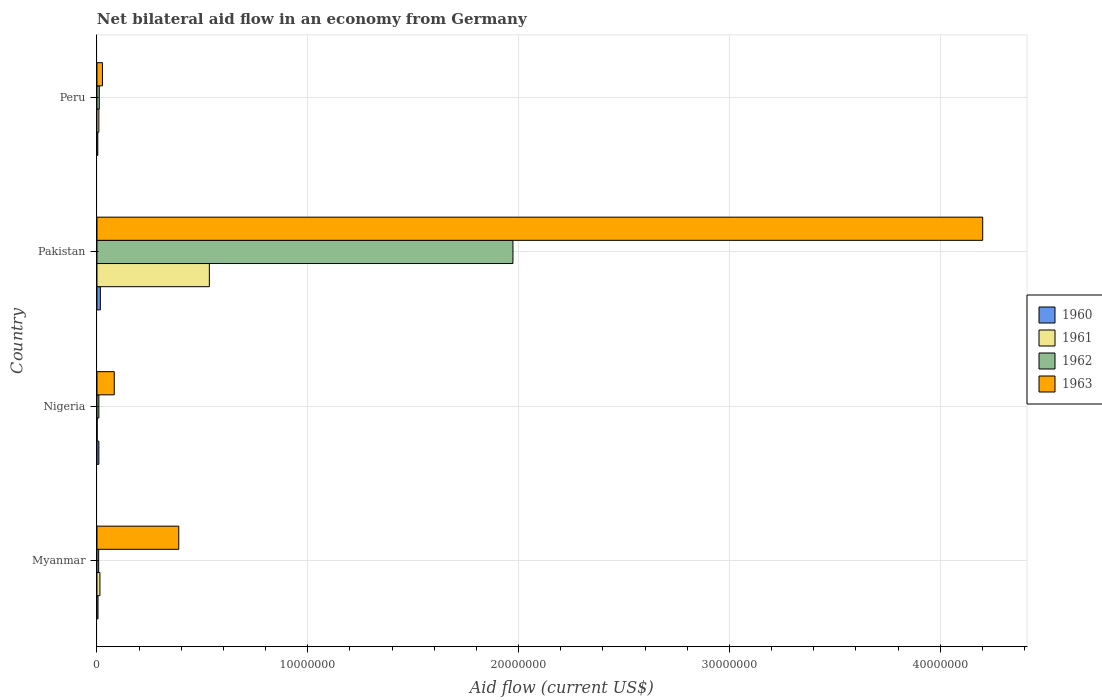How many groups of bars are there?
Make the answer very short. 4. Are the number of bars per tick equal to the number of legend labels?
Offer a terse response. Yes. How many bars are there on the 3rd tick from the top?
Your answer should be very brief. 4. What is the label of the 4th group of bars from the top?
Ensure brevity in your answer.  Myanmar. In how many cases, is the number of bars for a given country not equal to the number of legend labels?
Offer a terse response. 0. What is the net bilateral aid flow in 1961 in Nigeria?
Keep it short and to the point. 10000. Across all countries, what is the maximum net bilateral aid flow in 1960?
Your answer should be very brief. 1.60e+05. Across all countries, what is the minimum net bilateral aid flow in 1963?
Your answer should be compact. 2.60e+05. In which country was the net bilateral aid flow in 1961 minimum?
Offer a terse response. Nigeria. What is the total net bilateral aid flow in 1963 in the graph?
Offer a very short reply. 4.70e+07. What is the difference between the net bilateral aid flow in 1961 in Myanmar and that in Peru?
Keep it short and to the point. 5.00e+04. What is the average net bilateral aid flow in 1962 per country?
Make the answer very short. 5.00e+06. What is the difference between the net bilateral aid flow in 1960 and net bilateral aid flow in 1963 in Nigeria?
Provide a short and direct response. -7.30e+05. What is the ratio of the net bilateral aid flow in 1962 in Myanmar to that in Nigeria?
Provide a short and direct response. 0.89. Is the net bilateral aid flow in 1962 in Pakistan less than that in Peru?
Your response must be concise. No. What is the difference between the highest and the second highest net bilateral aid flow in 1962?
Keep it short and to the point. 1.96e+07. In how many countries, is the net bilateral aid flow in 1961 greater than the average net bilateral aid flow in 1961 taken over all countries?
Give a very brief answer. 1. Is the sum of the net bilateral aid flow in 1962 in Myanmar and Nigeria greater than the maximum net bilateral aid flow in 1961 across all countries?
Give a very brief answer. No. What does the 2nd bar from the top in Myanmar represents?
Give a very brief answer. 1962. How many bars are there?
Give a very brief answer. 16. Are all the bars in the graph horizontal?
Make the answer very short. Yes. What is the difference between two consecutive major ticks on the X-axis?
Ensure brevity in your answer.  1.00e+07. Does the graph contain any zero values?
Offer a very short reply. No. How are the legend labels stacked?
Give a very brief answer. Vertical. What is the title of the graph?
Your answer should be compact. Net bilateral aid flow in an economy from Germany. What is the label or title of the Y-axis?
Offer a terse response. Country. What is the Aid flow (current US$) of 1961 in Myanmar?
Keep it short and to the point. 1.40e+05. What is the Aid flow (current US$) in 1962 in Myanmar?
Your response must be concise. 8.00e+04. What is the Aid flow (current US$) of 1963 in Myanmar?
Keep it short and to the point. 3.88e+06. What is the Aid flow (current US$) in 1960 in Nigeria?
Provide a short and direct response. 9.00e+04. What is the Aid flow (current US$) in 1961 in Nigeria?
Give a very brief answer. 10000. What is the Aid flow (current US$) of 1963 in Nigeria?
Give a very brief answer. 8.20e+05. What is the Aid flow (current US$) in 1960 in Pakistan?
Your answer should be compact. 1.60e+05. What is the Aid flow (current US$) in 1961 in Pakistan?
Your response must be concise. 5.33e+06. What is the Aid flow (current US$) in 1962 in Pakistan?
Keep it short and to the point. 1.97e+07. What is the Aid flow (current US$) of 1963 in Pakistan?
Your response must be concise. 4.20e+07. What is the Aid flow (current US$) of 1960 in Peru?
Give a very brief answer. 4.00e+04. What is the Aid flow (current US$) in 1962 in Peru?
Offer a very short reply. 1.10e+05. Across all countries, what is the maximum Aid flow (current US$) of 1961?
Your answer should be compact. 5.33e+06. Across all countries, what is the maximum Aid flow (current US$) in 1962?
Offer a very short reply. 1.97e+07. Across all countries, what is the maximum Aid flow (current US$) of 1963?
Your response must be concise. 4.20e+07. Across all countries, what is the minimum Aid flow (current US$) of 1960?
Give a very brief answer. 4.00e+04. Across all countries, what is the minimum Aid flow (current US$) in 1962?
Keep it short and to the point. 8.00e+04. What is the total Aid flow (current US$) of 1961 in the graph?
Ensure brevity in your answer.  5.57e+06. What is the total Aid flow (current US$) of 1962 in the graph?
Your answer should be compact. 2.00e+07. What is the total Aid flow (current US$) in 1963 in the graph?
Your answer should be very brief. 4.70e+07. What is the difference between the Aid flow (current US$) in 1960 in Myanmar and that in Nigeria?
Your answer should be compact. -4.00e+04. What is the difference between the Aid flow (current US$) in 1963 in Myanmar and that in Nigeria?
Your answer should be very brief. 3.06e+06. What is the difference between the Aid flow (current US$) in 1961 in Myanmar and that in Pakistan?
Offer a very short reply. -5.19e+06. What is the difference between the Aid flow (current US$) of 1962 in Myanmar and that in Pakistan?
Provide a short and direct response. -1.96e+07. What is the difference between the Aid flow (current US$) in 1963 in Myanmar and that in Pakistan?
Give a very brief answer. -3.81e+07. What is the difference between the Aid flow (current US$) of 1961 in Myanmar and that in Peru?
Your response must be concise. 5.00e+04. What is the difference between the Aid flow (current US$) of 1963 in Myanmar and that in Peru?
Keep it short and to the point. 3.62e+06. What is the difference between the Aid flow (current US$) of 1961 in Nigeria and that in Pakistan?
Your answer should be compact. -5.32e+06. What is the difference between the Aid flow (current US$) in 1962 in Nigeria and that in Pakistan?
Ensure brevity in your answer.  -1.96e+07. What is the difference between the Aid flow (current US$) in 1963 in Nigeria and that in Pakistan?
Make the answer very short. -4.12e+07. What is the difference between the Aid flow (current US$) in 1960 in Nigeria and that in Peru?
Offer a terse response. 5.00e+04. What is the difference between the Aid flow (current US$) of 1962 in Nigeria and that in Peru?
Provide a succinct answer. -2.00e+04. What is the difference between the Aid flow (current US$) of 1963 in Nigeria and that in Peru?
Your answer should be very brief. 5.60e+05. What is the difference between the Aid flow (current US$) of 1960 in Pakistan and that in Peru?
Provide a short and direct response. 1.20e+05. What is the difference between the Aid flow (current US$) in 1961 in Pakistan and that in Peru?
Keep it short and to the point. 5.24e+06. What is the difference between the Aid flow (current US$) of 1962 in Pakistan and that in Peru?
Your answer should be compact. 1.96e+07. What is the difference between the Aid flow (current US$) of 1963 in Pakistan and that in Peru?
Keep it short and to the point. 4.18e+07. What is the difference between the Aid flow (current US$) of 1960 in Myanmar and the Aid flow (current US$) of 1963 in Nigeria?
Make the answer very short. -7.70e+05. What is the difference between the Aid flow (current US$) in 1961 in Myanmar and the Aid flow (current US$) in 1963 in Nigeria?
Your response must be concise. -6.80e+05. What is the difference between the Aid flow (current US$) of 1962 in Myanmar and the Aid flow (current US$) of 1963 in Nigeria?
Give a very brief answer. -7.40e+05. What is the difference between the Aid flow (current US$) of 1960 in Myanmar and the Aid flow (current US$) of 1961 in Pakistan?
Make the answer very short. -5.28e+06. What is the difference between the Aid flow (current US$) of 1960 in Myanmar and the Aid flow (current US$) of 1962 in Pakistan?
Your answer should be compact. -1.97e+07. What is the difference between the Aid flow (current US$) of 1960 in Myanmar and the Aid flow (current US$) of 1963 in Pakistan?
Provide a short and direct response. -4.20e+07. What is the difference between the Aid flow (current US$) in 1961 in Myanmar and the Aid flow (current US$) in 1962 in Pakistan?
Give a very brief answer. -1.96e+07. What is the difference between the Aid flow (current US$) of 1961 in Myanmar and the Aid flow (current US$) of 1963 in Pakistan?
Provide a short and direct response. -4.19e+07. What is the difference between the Aid flow (current US$) of 1962 in Myanmar and the Aid flow (current US$) of 1963 in Pakistan?
Offer a very short reply. -4.19e+07. What is the difference between the Aid flow (current US$) of 1960 in Myanmar and the Aid flow (current US$) of 1961 in Peru?
Make the answer very short. -4.00e+04. What is the difference between the Aid flow (current US$) of 1961 in Myanmar and the Aid flow (current US$) of 1962 in Peru?
Ensure brevity in your answer.  3.00e+04. What is the difference between the Aid flow (current US$) of 1961 in Myanmar and the Aid flow (current US$) of 1963 in Peru?
Your answer should be compact. -1.20e+05. What is the difference between the Aid flow (current US$) of 1960 in Nigeria and the Aid flow (current US$) of 1961 in Pakistan?
Ensure brevity in your answer.  -5.24e+06. What is the difference between the Aid flow (current US$) of 1960 in Nigeria and the Aid flow (current US$) of 1962 in Pakistan?
Provide a succinct answer. -1.96e+07. What is the difference between the Aid flow (current US$) of 1960 in Nigeria and the Aid flow (current US$) of 1963 in Pakistan?
Keep it short and to the point. -4.19e+07. What is the difference between the Aid flow (current US$) of 1961 in Nigeria and the Aid flow (current US$) of 1962 in Pakistan?
Your response must be concise. -1.97e+07. What is the difference between the Aid flow (current US$) of 1961 in Nigeria and the Aid flow (current US$) of 1963 in Pakistan?
Provide a succinct answer. -4.20e+07. What is the difference between the Aid flow (current US$) in 1962 in Nigeria and the Aid flow (current US$) in 1963 in Pakistan?
Give a very brief answer. -4.19e+07. What is the difference between the Aid flow (current US$) in 1960 in Nigeria and the Aid flow (current US$) in 1961 in Peru?
Provide a short and direct response. 0. What is the difference between the Aid flow (current US$) in 1960 in Nigeria and the Aid flow (current US$) in 1962 in Peru?
Your answer should be very brief. -2.00e+04. What is the difference between the Aid flow (current US$) in 1960 in Pakistan and the Aid flow (current US$) in 1961 in Peru?
Keep it short and to the point. 7.00e+04. What is the difference between the Aid flow (current US$) in 1961 in Pakistan and the Aid flow (current US$) in 1962 in Peru?
Give a very brief answer. 5.22e+06. What is the difference between the Aid flow (current US$) of 1961 in Pakistan and the Aid flow (current US$) of 1963 in Peru?
Your answer should be very brief. 5.07e+06. What is the difference between the Aid flow (current US$) in 1962 in Pakistan and the Aid flow (current US$) in 1963 in Peru?
Your response must be concise. 1.95e+07. What is the average Aid flow (current US$) in 1960 per country?
Your response must be concise. 8.50e+04. What is the average Aid flow (current US$) of 1961 per country?
Ensure brevity in your answer.  1.39e+06. What is the average Aid flow (current US$) of 1962 per country?
Ensure brevity in your answer.  5.00e+06. What is the average Aid flow (current US$) of 1963 per country?
Provide a succinct answer. 1.17e+07. What is the difference between the Aid flow (current US$) in 1960 and Aid flow (current US$) in 1961 in Myanmar?
Your response must be concise. -9.00e+04. What is the difference between the Aid flow (current US$) in 1960 and Aid flow (current US$) in 1963 in Myanmar?
Your answer should be compact. -3.83e+06. What is the difference between the Aid flow (current US$) of 1961 and Aid flow (current US$) of 1962 in Myanmar?
Offer a terse response. 6.00e+04. What is the difference between the Aid flow (current US$) of 1961 and Aid flow (current US$) of 1963 in Myanmar?
Your answer should be very brief. -3.74e+06. What is the difference between the Aid flow (current US$) in 1962 and Aid flow (current US$) in 1963 in Myanmar?
Keep it short and to the point. -3.80e+06. What is the difference between the Aid flow (current US$) of 1960 and Aid flow (current US$) of 1961 in Nigeria?
Make the answer very short. 8.00e+04. What is the difference between the Aid flow (current US$) in 1960 and Aid flow (current US$) in 1962 in Nigeria?
Give a very brief answer. 0. What is the difference between the Aid flow (current US$) of 1960 and Aid flow (current US$) of 1963 in Nigeria?
Offer a terse response. -7.30e+05. What is the difference between the Aid flow (current US$) in 1961 and Aid flow (current US$) in 1962 in Nigeria?
Keep it short and to the point. -8.00e+04. What is the difference between the Aid flow (current US$) in 1961 and Aid flow (current US$) in 1963 in Nigeria?
Keep it short and to the point. -8.10e+05. What is the difference between the Aid flow (current US$) of 1962 and Aid flow (current US$) of 1963 in Nigeria?
Make the answer very short. -7.30e+05. What is the difference between the Aid flow (current US$) in 1960 and Aid flow (current US$) in 1961 in Pakistan?
Keep it short and to the point. -5.17e+06. What is the difference between the Aid flow (current US$) of 1960 and Aid flow (current US$) of 1962 in Pakistan?
Make the answer very short. -1.96e+07. What is the difference between the Aid flow (current US$) in 1960 and Aid flow (current US$) in 1963 in Pakistan?
Your answer should be very brief. -4.18e+07. What is the difference between the Aid flow (current US$) of 1961 and Aid flow (current US$) of 1962 in Pakistan?
Make the answer very short. -1.44e+07. What is the difference between the Aid flow (current US$) in 1961 and Aid flow (current US$) in 1963 in Pakistan?
Make the answer very short. -3.67e+07. What is the difference between the Aid flow (current US$) in 1962 and Aid flow (current US$) in 1963 in Pakistan?
Keep it short and to the point. -2.23e+07. What is the difference between the Aid flow (current US$) in 1960 and Aid flow (current US$) in 1961 in Peru?
Provide a short and direct response. -5.00e+04. What is the difference between the Aid flow (current US$) of 1960 and Aid flow (current US$) of 1962 in Peru?
Offer a very short reply. -7.00e+04. What is the difference between the Aid flow (current US$) in 1961 and Aid flow (current US$) in 1963 in Peru?
Your response must be concise. -1.70e+05. What is the ratio of the Aid flow (current US$) in 1960 in Myanmar to that in Nigeria?
Keep it short and to the point. 0.56. What is the ratio of the Aid flow (current US$) in 1961 in Myanmar to that in Nigeria?
Give a very brief answer. 14. What is the ratio of the Aid flow (current US$) in 1963 in Myanmar to that in Nigeria?
Offer a terse response. 4.73. What is the ratio of the Aid flow (current US$) of 1960 in Myanmar to that in Pakistan?
Offer a terse response. 0.31. What is the ratio of the Aid flow (current US$) of 1961 in Myanmar to that in Pakistan?
Give a very brief answer. 0.03. What is the ratio of the Aid flow (current US$) of 1962 in Myanmar to that in Pakistan?
Keep it short and to the point. 0. What is the ratio of the Aid flow (current US$) of 1963 in Myanmar to that in Pakistan?
Make the answer very short. 0.09. What is the ratio of the Aid flow (current US$) in 1961 in Myanmar to that in Peru?
Make the answer very short. 1.56. What is the ratio of the Aid flow (current US$) in 1962 in Myanmar to that in Peru?
Ensure brevity in your answer.  0.73. What is the ratio of the Aid flow (current US$) of 1963 in Myanmar to that in Peru?
Offer a very short reply. 14.92. What is the ratio of the Aid flow (current US$) in 1960 in Nigeria to that in Pakistan?
Give a very brief answer. 0.56. What is the ratio of the Aid flow (current US$) in 1961 in Nigeria to that in Pakistan?
Offer a very short reply. 0. What is the ratio of the Aid flow (current US$) of 1962 in Nigeria to that in Pakistan?
Provide a succinct answer. 0. What is the ratio of the Aid flow (current US$) of 1963 in Nigeria to that in Pakistan?
Your answer should be compact. 0.02. What is the ratio of the Aid flow (current US$) of 1960 in Nigeria to that in Peru?
Your answer should be compact. 2.25. What is the ratio of the Aid flow (current US$) in 1962 in Nigeria to that in Peru?
Your response must be concise. 0.82. What is the ratio of the Aid flow (current US$) of 1963 in Nigeria to that in Peru?
Make the answer very short. 3.15. What is the ratio of the Aid flow (current US$) of 1960 in Pakistan to that in Peru?
Offer a very short reply. 4. What is the ratio of the Aid flow (current US$) in 1961 in Pakistan to that in Peru?
Offer a terse response. 59.22. What is the ratio of the Aid flow (current US$) in 1962 in Pakistan to that in Peru?
Your answer should be very brief. 179.36. What is the ratio of the Aid flow (current US$) in 1963 in Pakistan to that in Peru?
Provide a short and direct response. 161.58. What is the difference between the highest and the second highest Aid flow (current US$) of 1961?
Your response must be concise. 5.19e+06. What is the difference between the highest and the second highest Aid flow (current US$) in 1962?
Provide a succinct answer. 1.96e+07. What is the difference between the highest and the second highest Aid flow (current US$) of 1963?
Offer a very short reply. 3.81e+07. What is the difference between the highest and the lowest Aid flow (current US$) in 1960?
Ensure brevity in your answer.  1.20e+05. What is the difference between the highest and the lowest Aid flow (current US$) of 1961?
Keep it short and to the point. 5.32e+06. What is the difference between the highest and the lowest Aid flow (current US$) of 1962?
Offer a terse response. 1.96e+07. What is the difference between the highest and the lowest Aid flow (current US$) of 1963?
Give a very brief answer. 4.18e+07. 